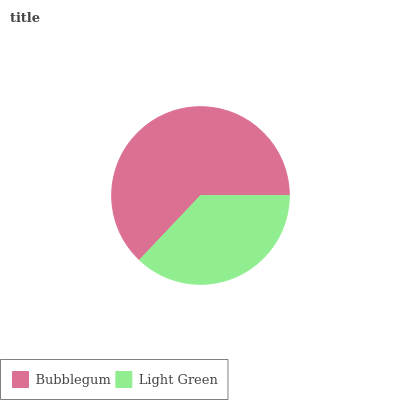Is Light Green the minimum?
Answer yes or no. Yes. Is Bubblegum the maximum?
Answer yes or no. Yes. Is Light Green the maximum?
Answer yes or no. No. Is Bubblegum greater than Light Green?
Answer yes or no. Yes. Is Light Green less than Bubblegum?
Answer yes or no. Yes. Is Light Green greater than Bubblegum?
Answer yes or no. No. Is Bubblegum less than Light Green?
Answer yes or no. No. Is Bubblegum the high median?
Answer yes or no. Yes. Is Light Green the low median?
Answer yes or no. Yes. Is Light Green the high median?
Answer yes or no. No. Is Bubblegum the low median?
Answer yes or no. No. 